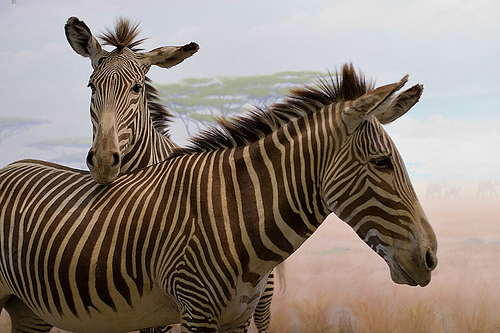Please provide a short description for this region: [0.32, 0.51, 0.41, 0.62]. This focus on the zebra's body shows a pattern of precise black and white stripes, each stripe uniquely aligned which contributes to its stunning visual camouflage in the wild. 